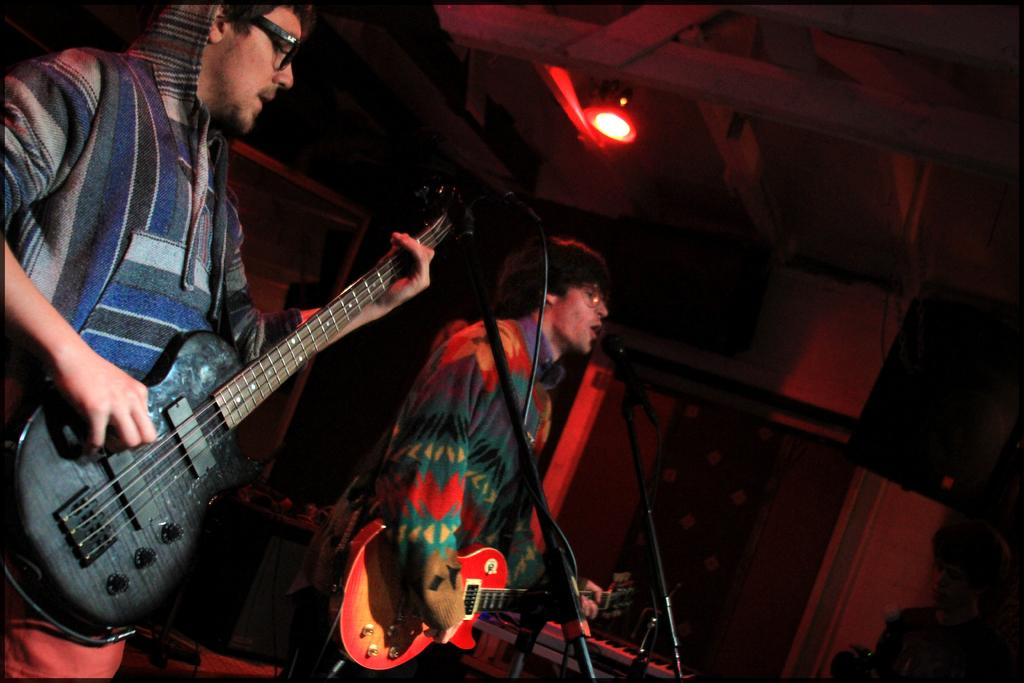How many people are in the image? There are two men in the image. What are the men doing in the image? The men are standing and holding guitars. What equipment is present in front of the men? There is a microphone with a stand in front of the men. What color is the light visible in the image? There is a red light visible in the image. What type of soup is being served in the image? There is no soup present in the image. Can you see a net in the image? There is no net visible in the image. 